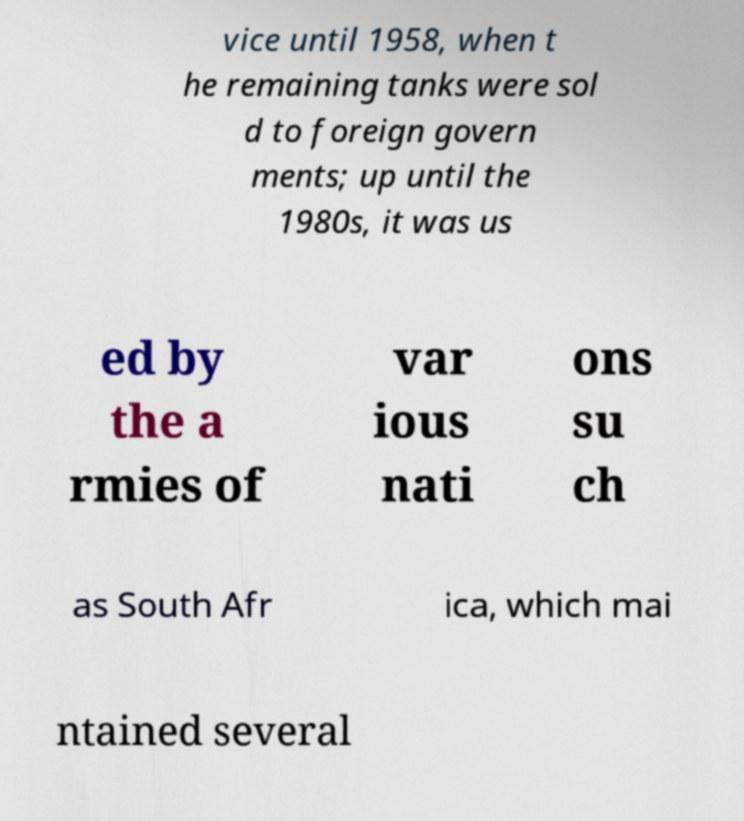Please identify and transcribe the text found in this image. vice until 1958, when t he remaining tanks were sol d to foreign govern ments; up until the 1980s, it was us ed by the a rmies of var ious nati ons su ch as South Afr ica, which mai ntained several 